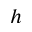<formula> <loc_0><loc_0><loc_500><loc_500>h</formula> 